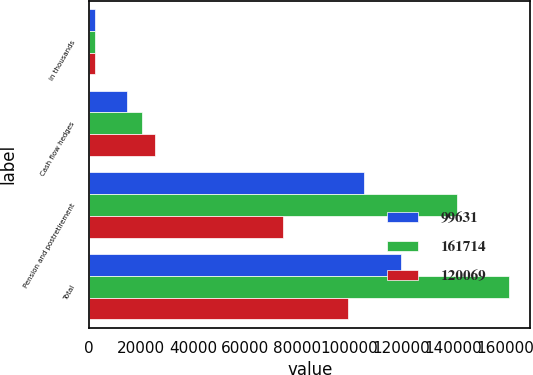Convert chart. <chart><loc_0><loc_0><loc_500><loc_500><stacked_bar_chart><ecel><fcel>in thousands<fcel>Cash flow hedges<fcel>Pension and postretirement<fcel>Total<nl><fcel>99631<fcel>2015<fcel>14494<fcel>105575<fcel>120069<nl><fcel>161714<fcel>2014<fcel>20322<fcel>141392<fcel>161714<nl><fcel>120069<fcel>2013<fcel>25178<fcel>74453<fcel>99631<nl></chart> 